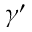Convert formula to latex. <formula><loc_0><loc_0><loc_500><loc_500>\gamma ^ { \prime }</formula> 